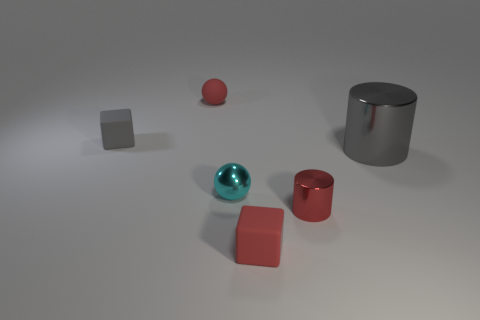Add 2 tiny purple rubber cubes. How many objects exist? 8 Subtract all brown matte cubes. Subtract all small cyan metal things. How many objects are left? 5 Add 4 small shiny objects. How many small shiny objects are left? 6 Add 1 tiny gray metallic blocks. How many tiny gray metallic blocks exist? 1 Subtract 0 blue cubes. How many objects are left? 6 Subtract all blocks. How many objects are left? 4 Subtract all red cubes. Subtract all purple cylinders. How many cubes are left? 1 